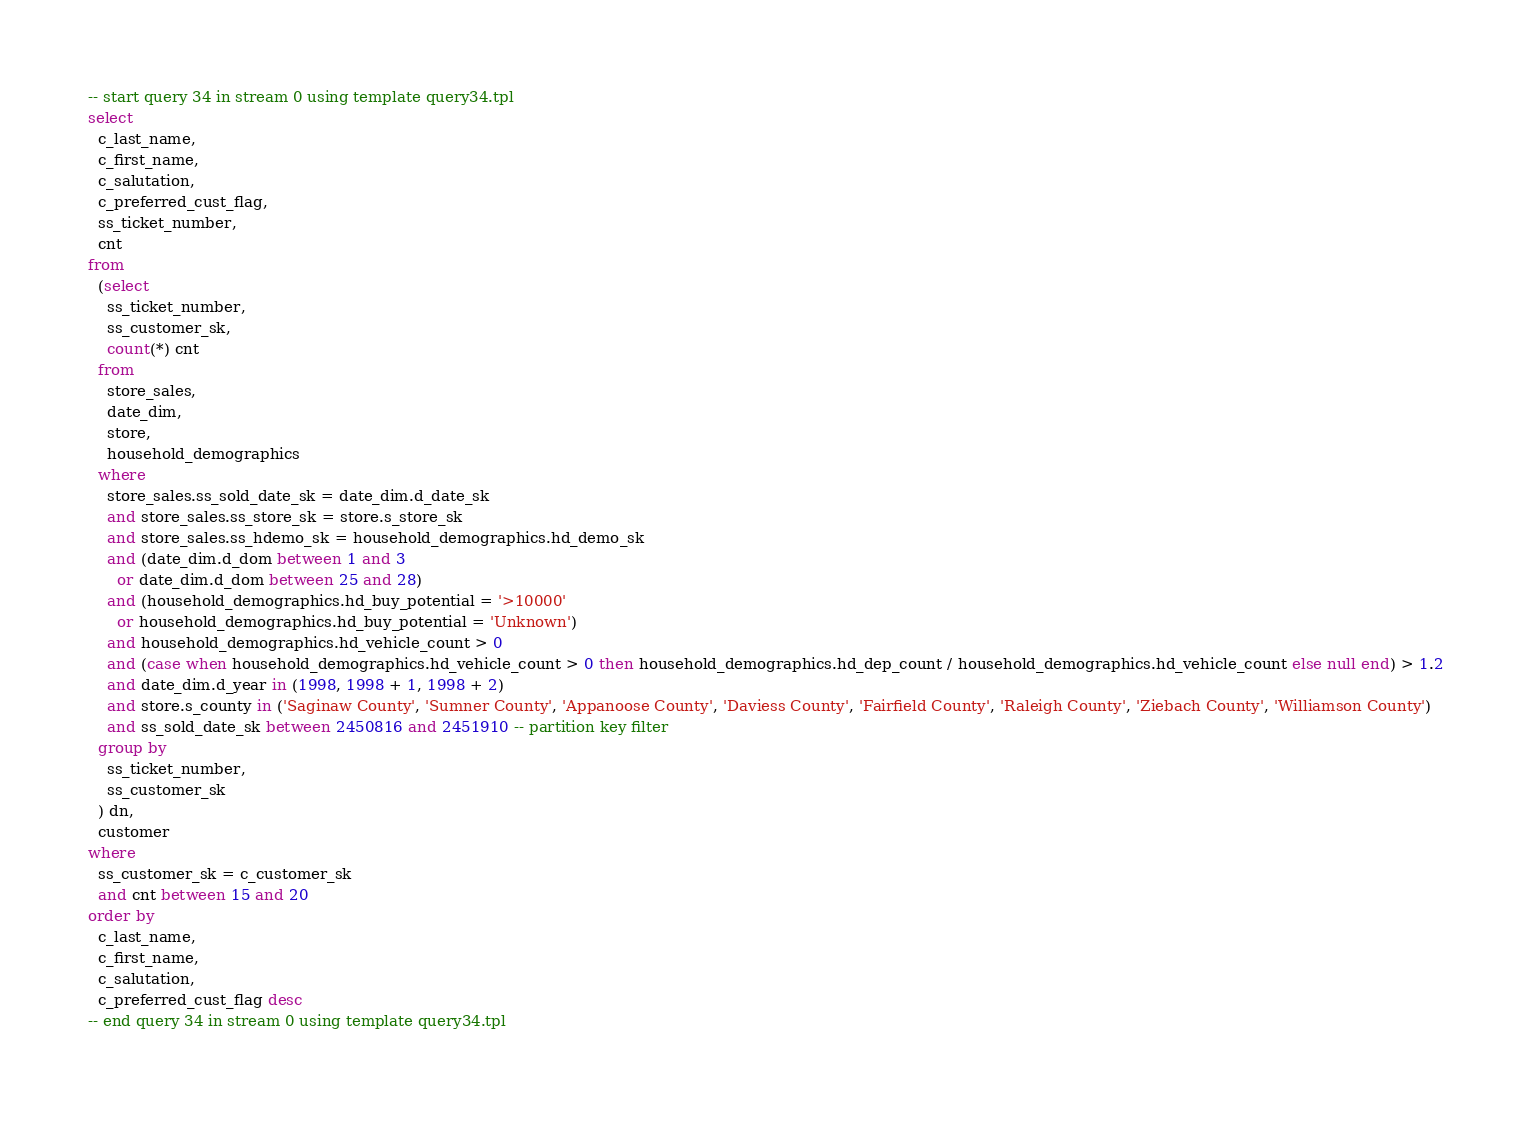<code> <loc_0><loc_0><loc_500><loc_500><_SQL_>-- start query 34 in stream 0 using template query34.tpl
select
  c_last_name,
  c_first_name,
  c_salutation,
  c_preferred_cust_flag,
  ss_ticket_number,
  cnt
from
  (select
    ss_ticket_number,
    ss_customer_sk,
    count(*) cnt
  from
    store_sales,
    date_dim,
    store,
    household_demographics
  where
    store_sales.ss_sold_date_sk = date_dim.d_date_sk
    and store_sales.ss_store_sk = store.s_store_sk
    and store_sales.ss_hdemo_sk = household_demographics.hd_demo_sk
    and (date_dim.d_dom between 1 and 3
      or date_dim.d_dom between 25 and 28)
    and (household_demographics.hd_buy_potential = '>10000'
      or household_demographics.hd_buy_potential = 'Unknown')
    and household_demographics.hd_vehicle_count > 0
    and (case when household_demographics.hd_vehicle_count > 0 then household_demographics.hd_dep_count / household_demographics.hd_vehicle_count else null end) > 1.2
    and date_dim.d_year in (1998, 1998 + 1, 1998 + 2)
    and store.s_county in ('Saginaw County', 'Sumner County', 'Appanoose County', 'Daviess County', 'Fairfield County', 'Raleigh County', 'Ziebach County', 'Williamson County')
    and ss_sold_date_sk between 2450816 and 2451910 -- partition key filter
  group by
    ss_ticket_number,
    ss_customer_sk
  ) dn,
  customer
where
  ss_customer_sk = c_customer_sk
  and cnt between 15 and 20
order by
  c_last_name,
  c_first_name,
  c_salutation,
  c_preferred_cust_flag desc
-- end query 34 in stream 0 using template query34.tpl
</code> 